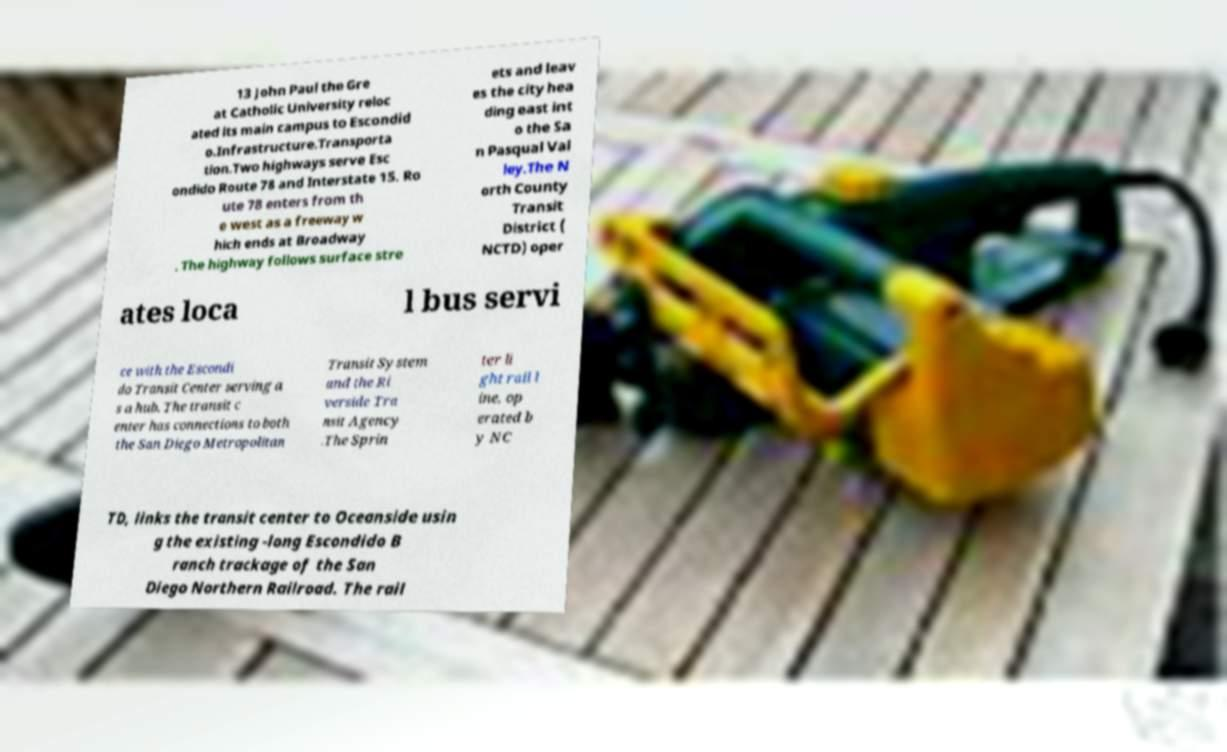Please read and relay the text visible in this image. What does it say? 13 John Paul the Gre at Catholic University reloc ated its main campus to Escondid o.Infrastructure.Transporta tion.Two highways serve Esc ondido Route 78 and Interstate 15. Ro ute 78 enters from th e west as a freeway w hich ends at Broadway . The highway follows surface stre ets and leav es the city hea ding east int o the Sa n Pasqual Val ley.The N orth County Transit District ( NCTD) oper ates loca l bus servi ce with the Escondi do Transit Center serving a s a hub. The transit c enter has connections to both the San Diego Metropolitan Transit System and the Ri verside Tra nsit Agency .The Sprin ter li ght rail l ine, op erated b y NC TD, links the transit center to Oceanside usin g the existing -long Escondido B ranch trackage of the San Diego Northern Railroad. The rail 